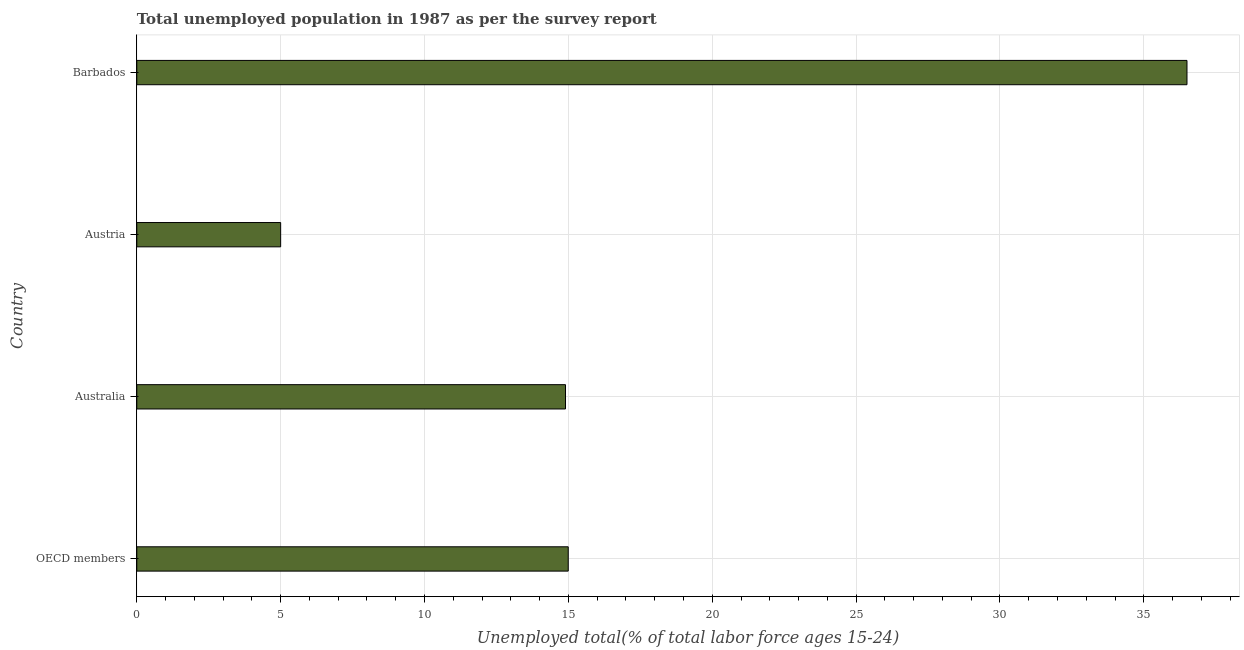What is the title of the graph?
Provide a short and direct response. Total unemployed population in 1987 as per the survey report. What is the label or title of the X-axis?
Offer a very short reply. Unemployed total(% of total labor force ages 15-24). What is the unemployed youth in OECD members?
Provide a short and direct response. 15. Across all countries, what is the maximum unemployed youth?
Keep it short and to the point. 36.5. Across all countries, what is the minimum unemployed youth?
Keep it short and to the point. 5. In which country was the unemployed youth maximum?
Provide a succinct answer. Barbados. What is the sum of the unemployed youth?
Ensure brevity in your answer.  71.4. What is the difference between the unemployed youth in Australia and Austria?
Provide a succinct answer. 9.9. What is the average unemployed youth per country?
Give a very brief answer. 17.85. What is the median unemployed youth?
Make the answer very short. 14.95. In how many countries, is the unemployed youth greater than 36 %?
Keep it short and to the point. 1. What is the ratio of the unemployed youth in Australia to that in Austria?
Ensure brevity in your answer.  2.98. Is the unemployed youth in Australia less than that in Barbados?
Provide a succinct answer. Yes. Is the difference between the unemployed youth in Barbados and OECD members greater than the difference between any two countries?
Give a very brief answer. No. What is the difference between the highest and the second highest unemployed youth?
Ensure brevity in your answer.  21.5. What is the difference between the highest and the lowest unemployed youth?
Make the answer very short. 31.5. How many bars are there?
Ensure brevity in your answer.  4. Are all the bars in the graph horizontal?
Offer a very short reply. Yes. How many countries are there in the graph?
Give a very brief answer. 4. What is the difference between two consecutive major ticks on the X-axis?
Your answer should be very brief. 5. What is the Unemployed total(% of total labor force ages 15-24) in OECD members?
Your answer should be compact. 15. What is the Unemployed total(% of total labor force ages 15-24) in Australia?
Ensure brevity in your answer.  14.9. What is the Unemployed total(% of total labor force ages 15-24) in Barbados?
Your response must be concise. 36.5. What is the difference between the Unemployed total(% of total labor force ages 15-24) in OECD members and Australia?
Provide a succinct answer. 0.1. What is the difference between the Unemployed total(% of total labor force ages 15-24) in OECD members and Austria?
Your answer should be compact. 10. What is the difference between the Unemployed total(% of total labor force ages 15-24) in OECD members and Barbados?
Your response must be concise. -21.5. What is the difference between the Unemployed total(% of total labor force ages 15-24) in Australia and Barbados?
Your answer should be compact. -21.6. What is the difference between the Unemployed total(% of total labor force ages 15-24) in Austria and Barbados?
Provide a short and direct response. -31.5. What is the ratio of the Unemployed total(% of total labor force ages 15-24) in OECD members to that in Australia?
Your response must be concise. 1.01. What is the ratio of the Unemployed total(% of total labor force ages 15-24) in OECD members to that in Austria?
Offer a terse response. 3. What is the ratio of the Unemployed total(% of total labor force ages 15-24) in OECD members to that in Barbados?
Make the answer very short. 0.41. What is the ratio of the Unemployed total(% of total labor force ages 15-24) in Australia to that in Austria?
Offer a terse response. 2.98. What is the ratio of the Unemployed total(% of total labor force ages 15-24) in Australia to that in Barbados?
Ensure brevity in your answer.  0.41. What is the ratio of the Unemployed total(% of total labor force ages 15-24) in Austria to that in Barbados?
Offer a very short reply. 0.14. 